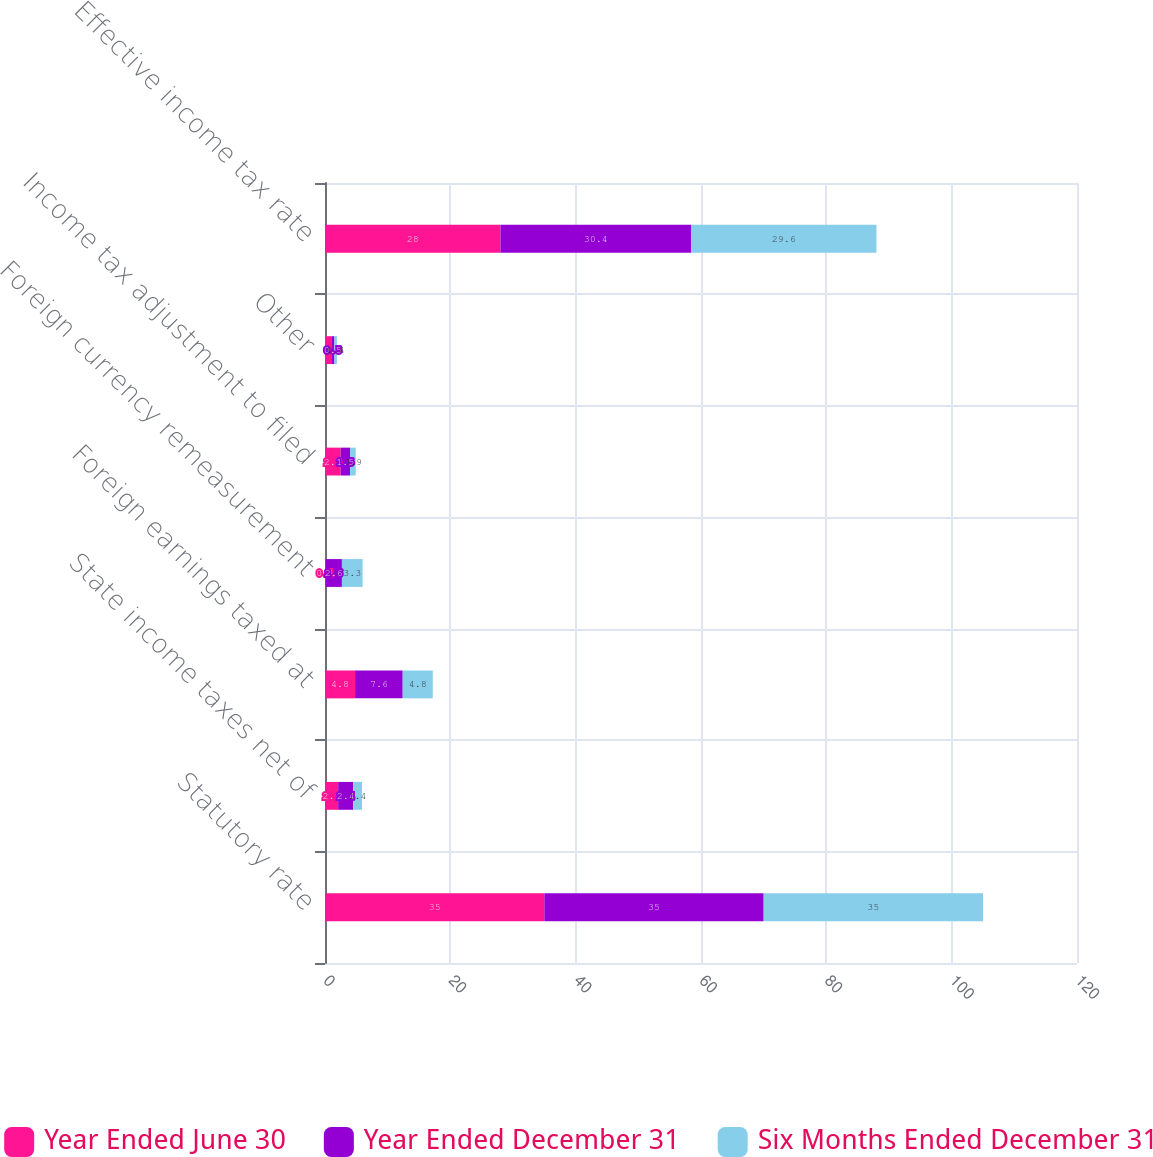Convert chart. <chart><loc_0><loc_0><loc_500><loc_500><stacked_bar_chart><ecel><fcel>Statutory rate<fcel>State income taxes net of<fcel>Foreign earnings taxed at<fcel>Foreign currency remeasurement<fcel>Income tax adjustment to filed<fcel>Other<fcel>Effective income tax rate<nl><fcel>Year Ended June 30<fcel>35<fcel>2.1<fcel>4.8<fcel>0.1<fcel>2.5<fcel>1<fcel>28<nl><fcel>Year Ended December 31<fcel>35<fcel>2.4<fcel>7.6<fcel>2.6<fcel>1.5<fcel>0.5<fcel>30.4<nl><fcel>Six Months Ended December 31<fcel>35<fcel>1.4<fcel>4.8<fcel>3.3<fcel>0.9<fcel>0.4<fcel>29.6<nl></chart> 